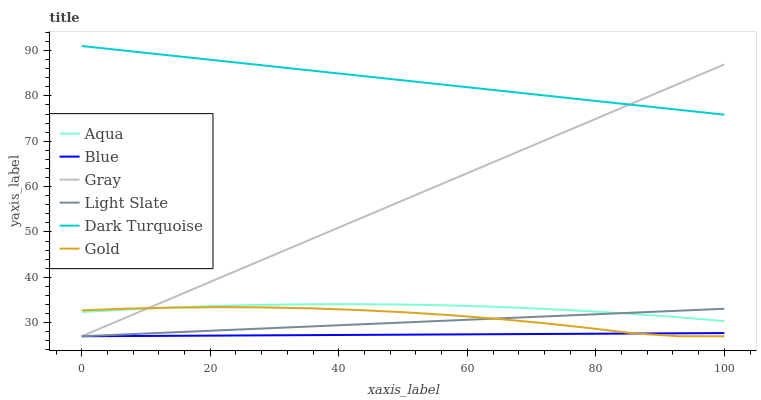Does Blue have the minimum area under the curve?
Answer yes or no. Yes. Does Dark Turquoise have the maximum area under the curve?
Answer yes or no. Yes. Does Gray have the minimum area under the curve?
Answer yes or no. No. Does Gray have the maximum area under the curve?
Answer yes or no. No. Is Blue the smoothest?
Answer yes or no. Yes. Is Gold the roughest?
Answer yes or no. Yes. Is Gray the smoothest?
Answer yes or no. No. Is Gray the roughest?
Answer yes or no. No. Does Blue have the lowest value?
Answer yes or no. Yes. Does Dark Turquoise have the lowest value?
Answer yes or no. No. Does Dark Turquoise have the highest value?
Answer yes or no. Yes. Does Gray have the highest value?
Answer yes or no. No. Is Light Slate less than Dark Turquoise?
Answer yes or no. Yes. Is Dark Turquoise greater than Aqua?
Answer yes or no. Yes. Does Aqua intersect Gray?
Answer yes or no. Yes. Is Aqua less than Gray?
Answer yes or no. No. Is Aqua greater than Gray?
Answer yes or no. No. Does Light Slate intersect Dark Turquoise?
Answer yes or no. No. 